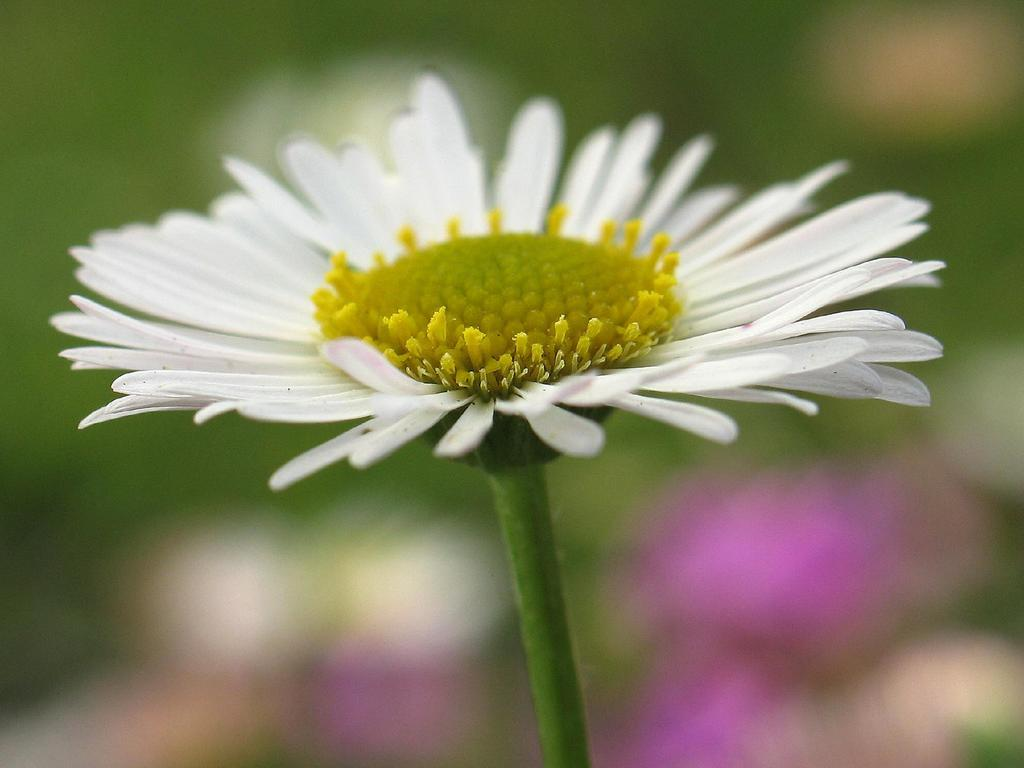What is the main subject of the image? There is a flower in the image. What colors can be seen on the flower? The flower has white and yellow colors. How is the flower positioned in the image? The flower is blurred in the background. What type of cork can be seen in the aftermath of the exchange in the image? There is no cork or exchange present in the image; it features a flower with white and yellow colors that is blurred in the background. 